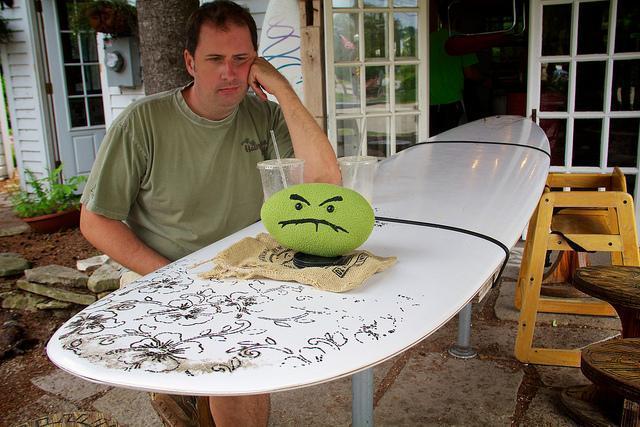What facial expression is the green ball showing?
Choose the right answer and clarify with the format: 'Answer: answer
Rationale: rationale.'
Options: Fear, anger, happiness, confusion. Answer: anger.
Rationale: It is frowning and its eyebrows are furrowed. 